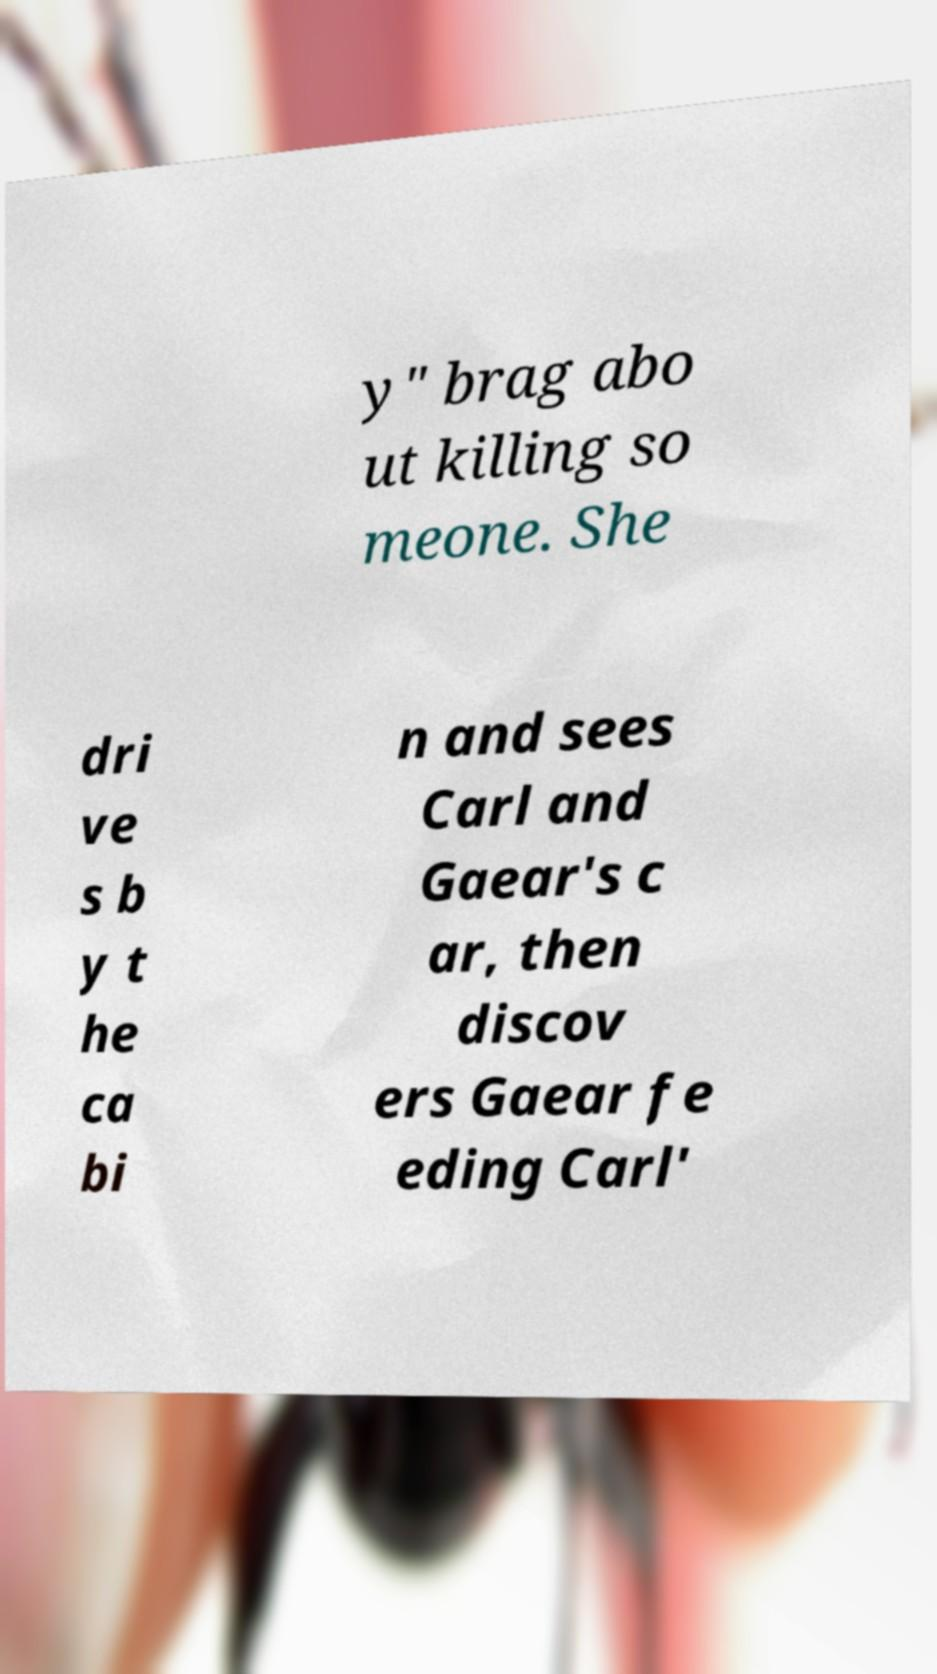Could you assist in decoding the text presented in this image and type it out clearly? y" brag abo ut killing so meone. She dri ve s b y t he ca bi n and sees Carl and Gaear's c ar, then discov ers Gaear fe eding Carl' 